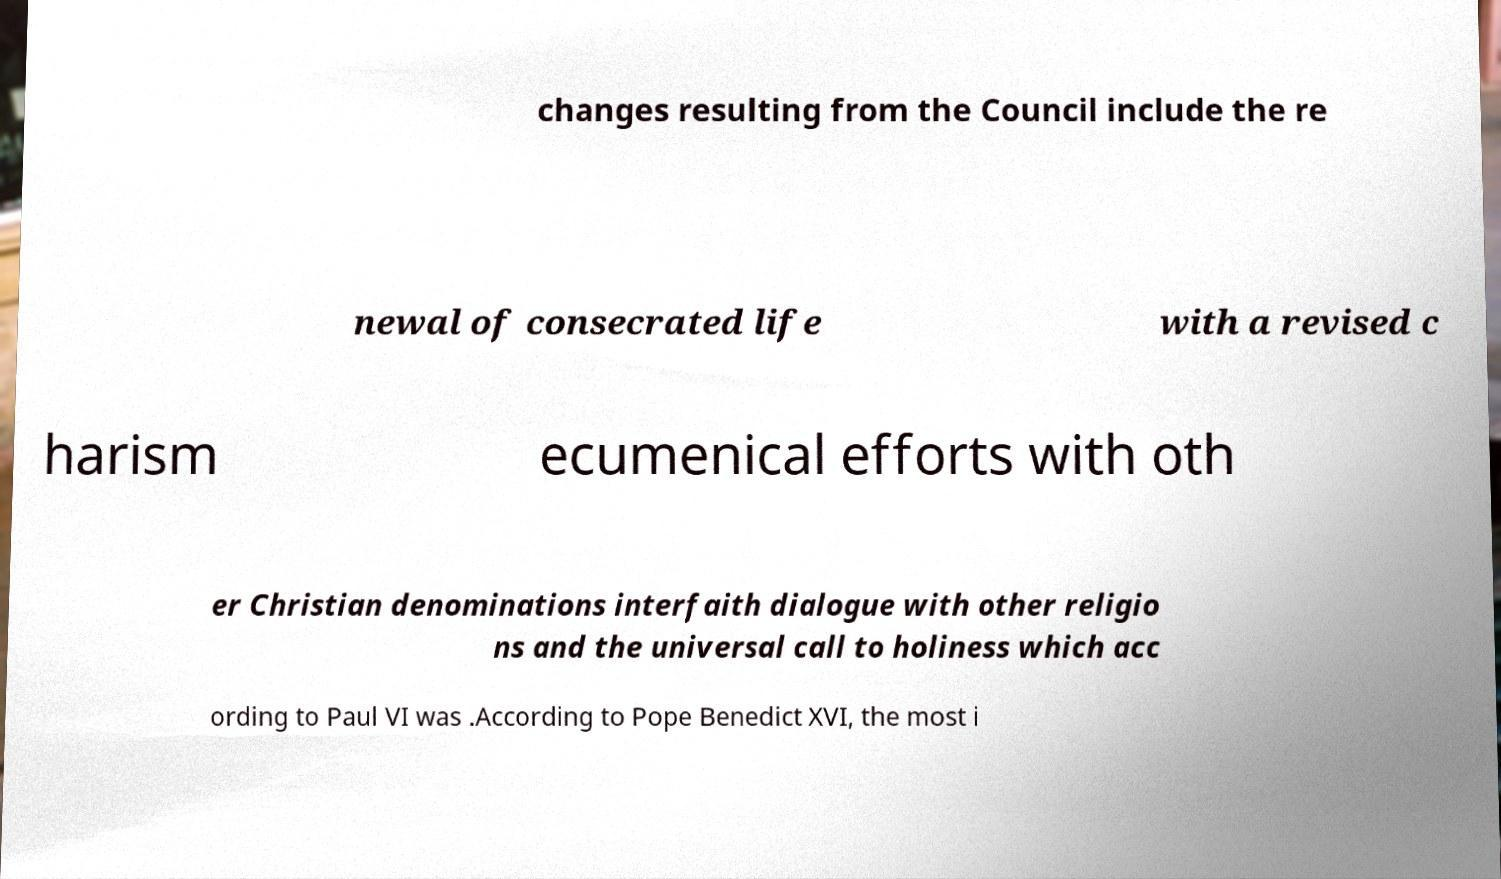There's text embedded in this image that I need extracted. Can you transcribe it verbatim? changes resulting from the Council include the re newal of consecrated life with a revised c harism ecumenical efforts with oth er Christian denominations interfaith dialogue with other religio ns and the universal call to holiness which acc ording to Paul VI was .According to Pope Benedict XVI, the most i 